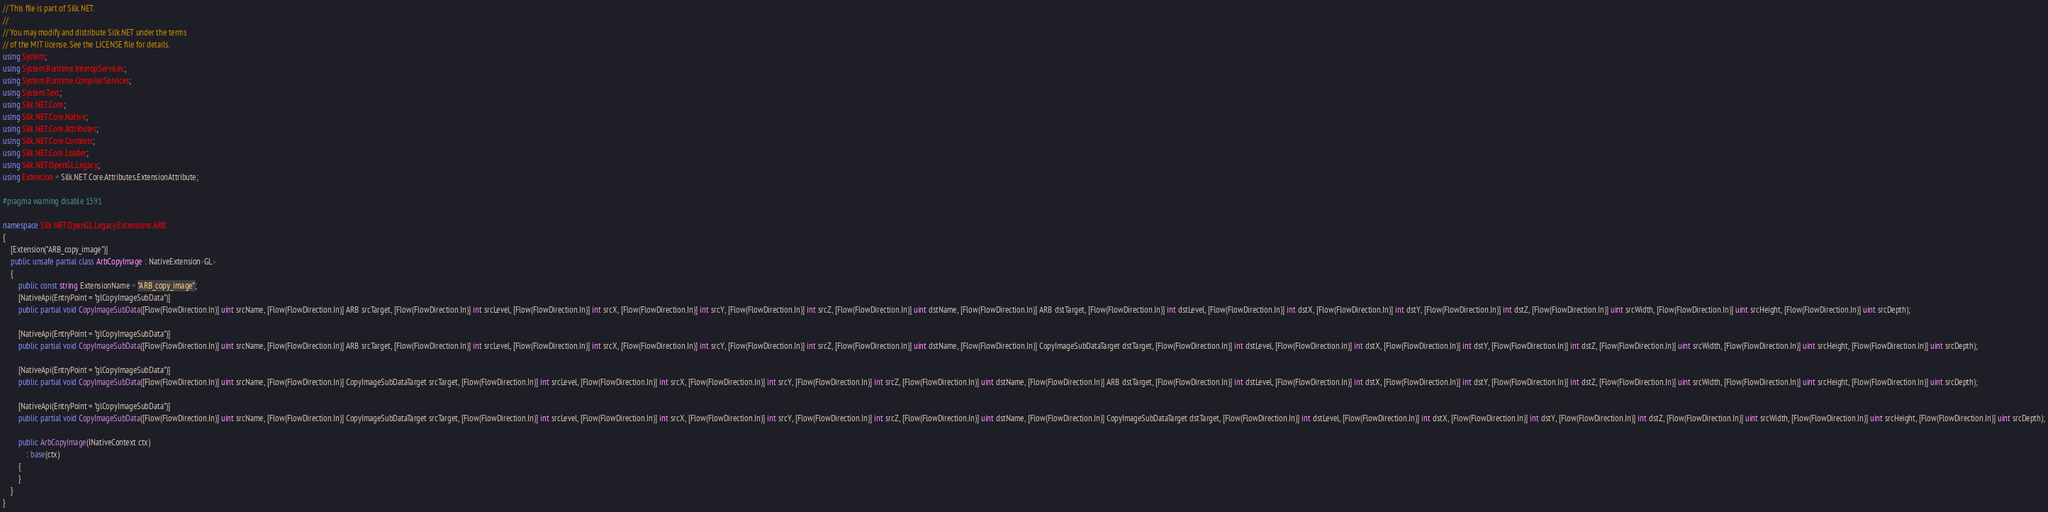<code> <loc_0><loc_0><loc_500><loc_500><_C#_>// This file is part of Silk.NET.
// 
// You may modify and distribute Silk.NET under the terms
// of the MIT license. See the LICENSE file for details.
using System;
using System.Runtime.InteropServices;
using System.Runtime.CompilerServices;
using System.Text;
using Silk.NET.Core;
using Silk.NET.Core.Native;
using Silk.NET.Core.Attributes;
using Silk.NET.Core.Contexts;
using Silk.NET.Core.Loader;
using Silk.NET.OpenGL.Legacy;
using Extension = Silk.NET.Core.Attributes.ExtensionAttribute;

#pragma warning disable 1591

namespace Silk.NET.OpenGL.Legacy.Extensions.ARB
{
    [Extension("ARB_copy_image")]
    public unsafe partial class ArbCopyImage : NativeExtension<GL>
    {
        public const string ExtensionName = "ARB_copy_image";
        [NativeApi(EntryPoint = "glCopyImageSubData")]
        public partial void CopyImageSubData([Flow(FlowDirection.In)] uint srcName, [Flow(FlowDirection.In)] ARB srcTarget, [Flow(FlowDirection.In)] int srcLevel, [Flow(FlowDirection.In)] int srcX, [Flow(FlowDirection.In)] int srcY, [Flow(FlowDirection.In)] int srcZ, [Flow(FlowDirection.In)] uint dstName, [Flow(FlowDirection.In)] ARB dstTarget, [Flow(FlowDirection.In)] int dstLevel, [Flow(FlowDirection.In)] int dstX, [Flow(FlowDirection.In)] int dstY, [Flow(FlowDirection.In)] int dstZ, [Flow(FlowDirection.In)] uint srcWidth, [Flow(FlowDirection.In)] uint srcHeight, [Flow(FlowDirection.In)] uint srcDepth);

        [NativeApi(EntryPoint = "glCopyImageSubData")]
        public partial void CopyImageSubData([Flow(FlowDirection.In)] uint srcName, [Flow(FlowDirection.In)] ARB srcTarget, [Flow(FlowDirection.In)] int srcLevel, [Flow(FlowDirection.In)] int srcX, [Flow(FlowDirection.In)] int srcY, [Flow(FlowDirection.In)] int srcZ, [Flow(FlowDirection.In)] uint dstName, [Flow(FlowDirection.In)] CopyImageSubDataTarget dstTarget, [Flow(FlowDirection.In)] int dstLevel, [Flow(FlowDirection.In)] int dstX, [Flow(FlowDirection.In)] int dstY, [Flow(FlowDirection.In)] int dstZ, [Flow(FlowDirection.In)] uint srcWidth, [Flow(FlowDirection.In)] uint srcHeight, [Flow(FlowDirection.In)] uint srcDepth);

        [NativeApi(EntryPoint = "glCopyImageSubData")]
        public partial void CopyImageSubData([Flow(FlowDirection.In)] uint srcName, [Flow(FlowDirection.In)] CopyImageSubDataTarget srcTarget, [Flow(FlowDirection.In)] int srcLevel, [Flow(FlowDirection.In)] int srcX, [Flow(FlowDirection.In)] int srcY, [Flow(FlowDirection.In)] int srcZ, [Flow(FlowDirection.In)] uint dstName, [Flow(FlowDirection.In)] ARB dstTarget, [Flow(FlowDirection.In)] int dstLevel, [Flow(FlowDirection.In)] int dstX, [Flow(FlowDirection.In)] int dstY, [Flow(FlowDirection.In)] int dstZ, [Flow(FlowDirection.In)] uint srcWidth, [Flow(FlowDirection.In)] uint srcHeight, [Flow(FlowDirection.In)] uint srcDepth);

        [NativeApi(EntryPoint = "glCopyImageSubData")]
        public partial void CopyImageSubData([Flow(FlowDirection.In)] uint srcName, [Flow(FlowDirection.In)] CopyImageSubDataTarget srcTarget, [Flow(FlowDirection.In)] int srcLevel, [Flow(FlowDirection.In)] int srcX, [Flow(FlowDirection.In)] int srcY, [Flow(FlowDirection.In)] int srcZ, [Flow(FlowDirection.In)] uint dstName, [Flow(FlowDirection.In)] CopyImageSubDataTarget dstTarget, [Flow(FlowDirection.In)] int dstLevel, [Flow(FlowDirection.In)] int dstX, [Flow(FlowDirection.In)] int dstY, [Flow(FlowDirection.In)] int dstZ, [Flow(FlowDirection.In)] uint srcWidth, [Flow(FlowDirection.In)] uint srcHeight, [Flow(FlowDirection.In)] uint srcDepth);

        public ArbCopyImage(INativeContext ctx)
            : base(ctx)
        {
        }
    }
}

</code> 